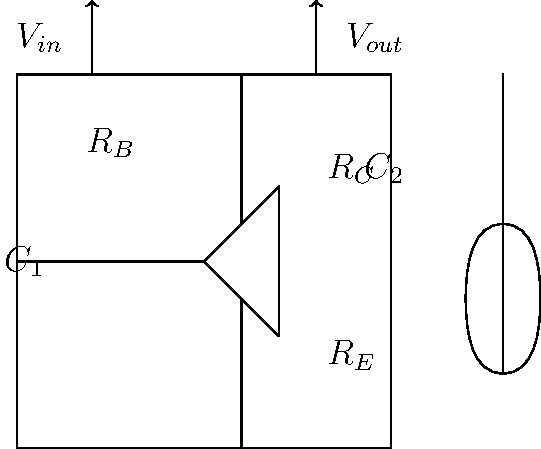Design a common-emitter amplifier circuit for Bruce Springsteen's electric guitar, assuming a voltage gain of 100 and a collector current of 1 mA. Given that the transistor's $\beta = 100$ and $V_{CC} = 9V$, calculate the value of the emitter resistor $R_E$. How does this amplifier contribute to the Boss's iconic guitar sound? Let's break this down step-by-step, keeping in mind the importance of this circuit to Bruce Springsteen's legendary sound:

1) For a common-emitter amplifier, the voltage gain $A_v$ is given by:
   $A_v = -\frac{R_C}{R_E}$

2) We're given that $A_v = 100$, so:
   $100 = \frac{R_C}{R_E}$

3) In a common-emitter amplifier, $R_C$ is typically chosen to be about half of $V_{CC}$ divided by $I_C$:
   $R_C = \frac{V_{CC}}{2I_C} = \frac{9V}{2(1mA)} = 4.5k\Omega$

4) Now we can find $R_E$:
   $R_E = \frac{R_C}{100} = \frac{4.5k\Omega}{100} = 45\Omega$

5) To verify stability, we should check if $R_E > \frac{25mV}{I_E}$:
   $I_E \approx I_C = 1mA$
   $\frac{25mV}{I_E} = \frac{25mV}{1mA} = 25\Omega$
   $45\Omega > 25\Omega$, so the circuit is stable.

6) This amplifier design, with its high gain, would contribute significantly to Springsteen's powerful, overdriven guitar tone. The common-emitter configuration allows for both voltage and current gain, providing the "bite" and "growl" characteristic of the Boss's sound. The relatively low $R_E$ value allows for a higher gain, which is crucial for achieving that raw, energetic tone that defines Springsteen's music.
Answer: $R_E = 45\Omega$ 